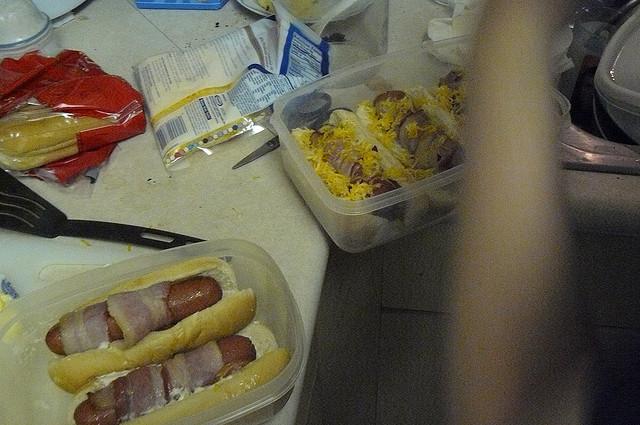Do you see a spatula?
Short answer required. Yes. What is in the red bag?
Give a very brief answer. Hot dog buns. What topping is on the hot dog?
Answer briefly. Bacon. What is wrapped around the hotdogs on the left?
Short answer required. Bacon. 